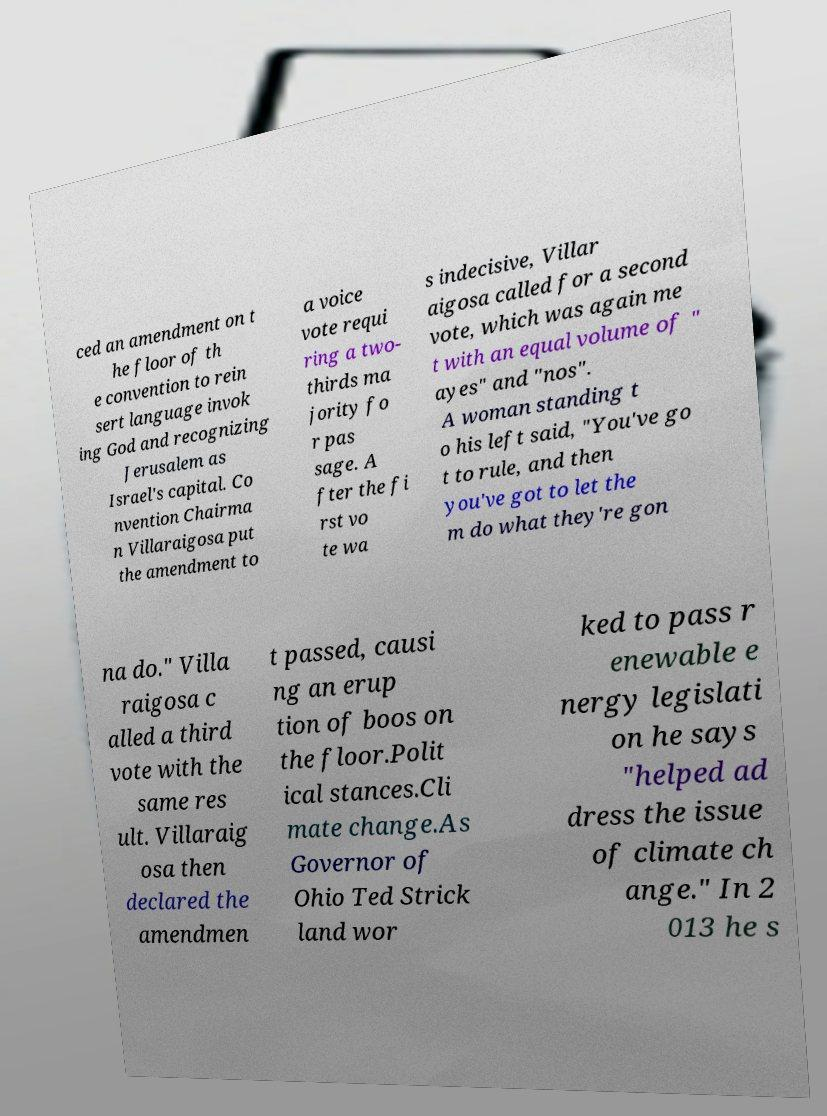Could you assist in decoding the text presented in this image and type it out clearly? ced an amendment on t he floor of th e convention to rein sert language invok ing God and recognizing Jerusalem as Israel's capital. Co nvention Chairma n Villaraigosa put the amendment to a voice vote requi ring a two- thirds ma jority fo r pas sage. A fter the fi rst vo te wa s indecisive, Villar aigosa called for a second vote, which was again me t with an equal volume of " ayes" and "nos". A woman standing t o his left said, "You've go t to rule, and then you've got to let the m do what they're gon na do." Villa raigosa c alled a third vote with the same res ult. Villaraig osa then declared the amendmen t passed, causi ng an erup tion of boos on the floor.Polit ical stances.Cli mate change.As Governor of Ohio Ted Strick land wor ked to pass r enewable e nergy legislati on he says "helped ad dress the issue of climate ch ange." In 2 013 he s 